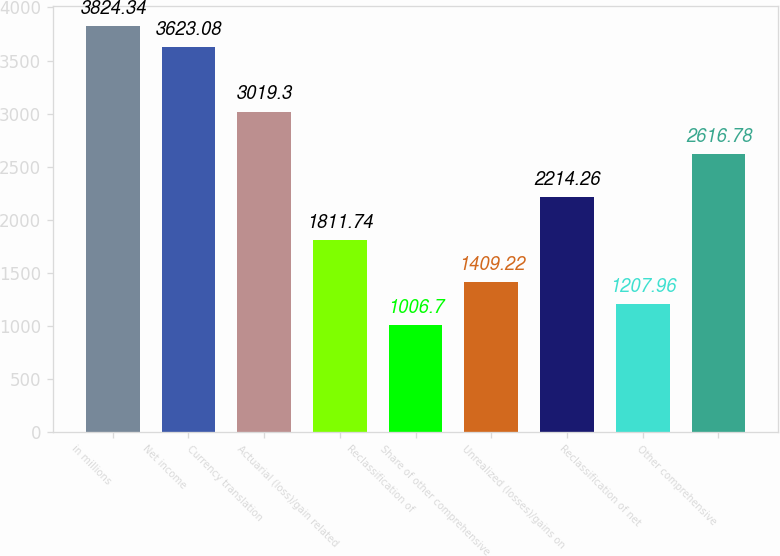Convert chart. <chart><loc_0><loc_0><loc_500><loc_500><bar_chart><fcel>in millions<fcel>Net income<fcel>Currency translation<fcel>Actuarial (loss)/gain related<fcel>Reclassification of<fcel>Share of other comprehensive<fcel>Unrealized (losses)/gains on<fcel>Reclassification of net<fcel>Other comprehensive<nl><fcel>3824.34<fcel>3623.08<fcel>3019.3<fcel>1811.74<fcel>1006.7<fcel>1409.22<fcel>2214.26<fcel>1207.96<fcel>2616.78<nl></chart> 